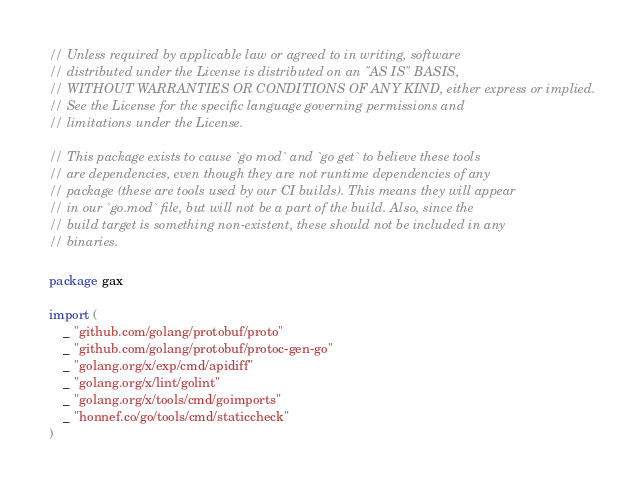<code> <loc_0><loc_0><loc_500><loc_500><_Go_>// Unless required by applicable law or agreed to in writing, software
// distributed under the License is distributed on an "AS IS" BASIS,
// WITHOUT WARRANTIES OR CONDITIONS OF ANY KIND, either express or implied.
// See the License for the specific language governing permissions and
// limitations under the License.

// This package exists to cause `go mod` and `go get` to believe these tools
// are dependencies, even though they are not runtime dependencies of any
// package (these are tools used by our CI builds). This means they will appear
// in our `go.mod` file, but will not be a part of the build. Also, since the
// build target is something non-existent, these should not be included in any
// binaries.

package gax

import (
	_ "github.com/golang/protobuf/proto"
	_ "github.com/golang/protobuf/protoc-gen-go"
	_ "golang.org/x/exp/cmd/apidiff"
	_ "golang.org/x/lint/golint"
	_ "golang.org/x/tools/cmd/goimports"
	_ "honnef.co/go/tools/cmd/staticcheck"
)
</code> 